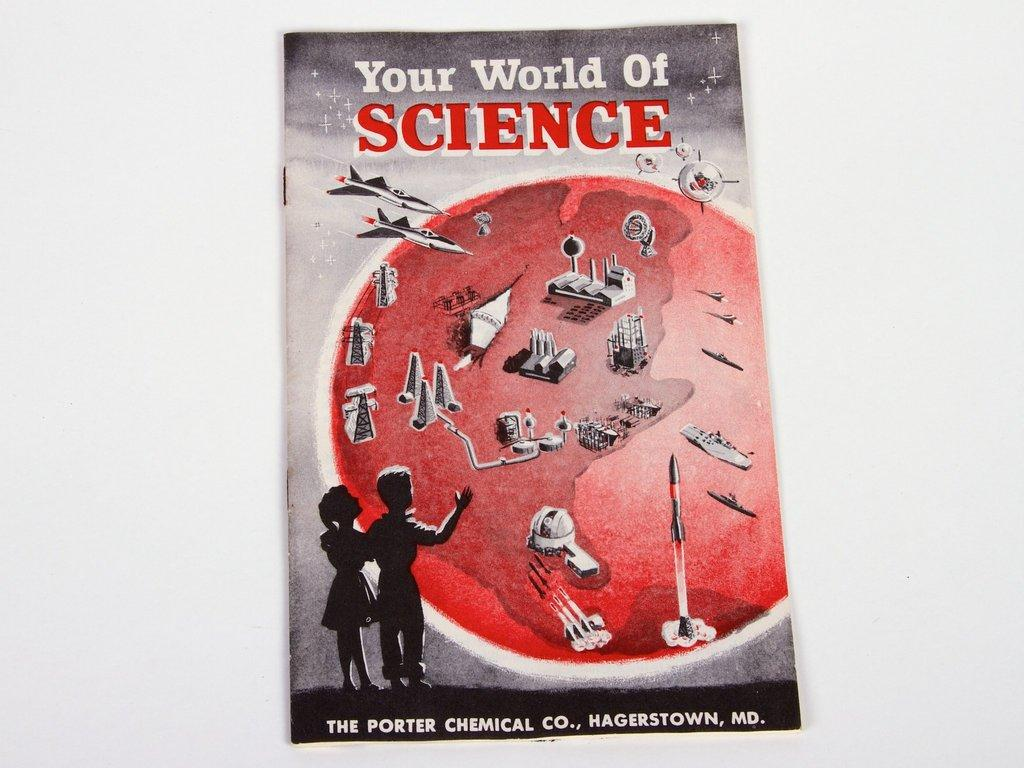<image>
Share a concise interpretation of the image provided. A book with two children titled Your World of Science. 